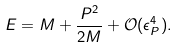<formula> <loc_0><loc_0><loc_500><loc_500>E = M + \frac { P ^ { 2 } } { 2 M } + { \mathcal { O } } ( \epsilon _ { P } ^ { 4 } ) .</formula> 